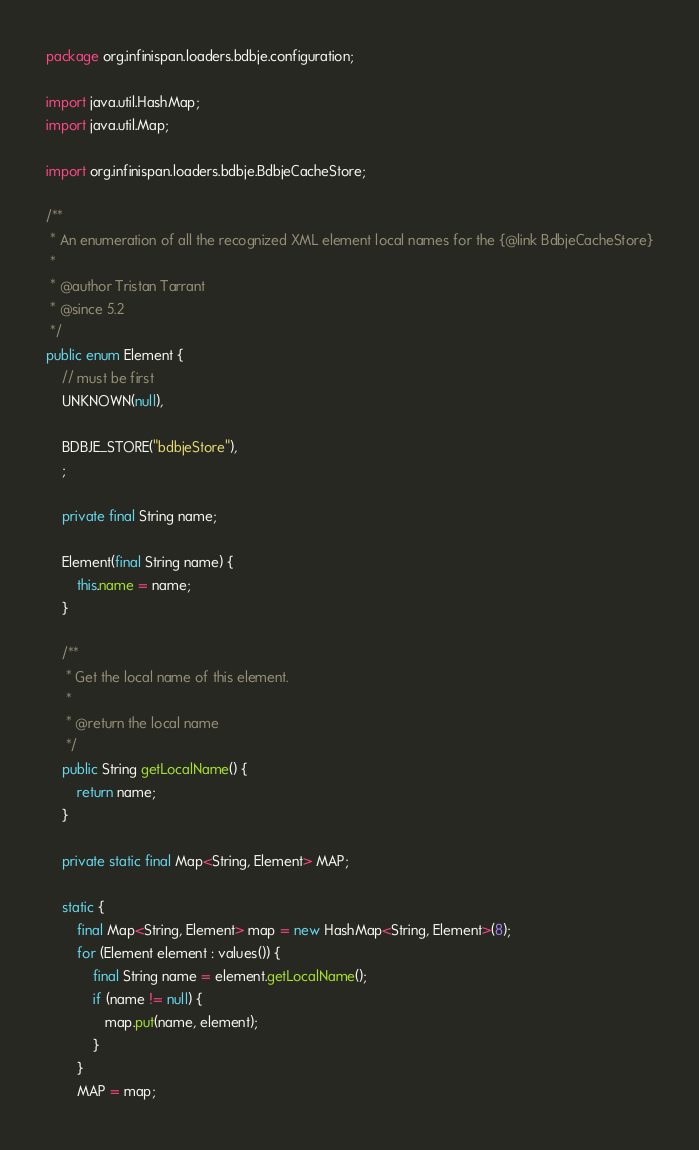<code> <loc_0><loc_0><loc_500><loc_500><_Java_>package org.infinispan.loaders.bdbje.configuration;

import java.util.HashMap;
import java.util.Map;

import org.infinispan.loaders.bdbje.BdbjeCacheStore;

/**
 * An enumeration of all the recognized XML element local names for the {@link BdbjeCacheStore}
 *
 * @author Tristan Tarrant
 * @since 5.2
 */
public enum Element {
    // must be first
    UNKNOWN(null),

    BDBJE_STORE("bdbjeStore"),
    ;

    private final String name;

    Element(final String name) {
        this.name = name;
    }

    /**
     * Get the local name of this element.
     *
     * @return the local name
     */
    public String getLocalName() {
        return name;
    }

    private static final Map<String, Element> MAP;

    static {
        final Map<String, Element> map = new HashMap<String, Element>(8);
        for (Element element : values()) {
            final String name = element.getLocalName();
            if (name != null) {
               map.put(name, element);
            }
        }
        MAP = map;</code> 